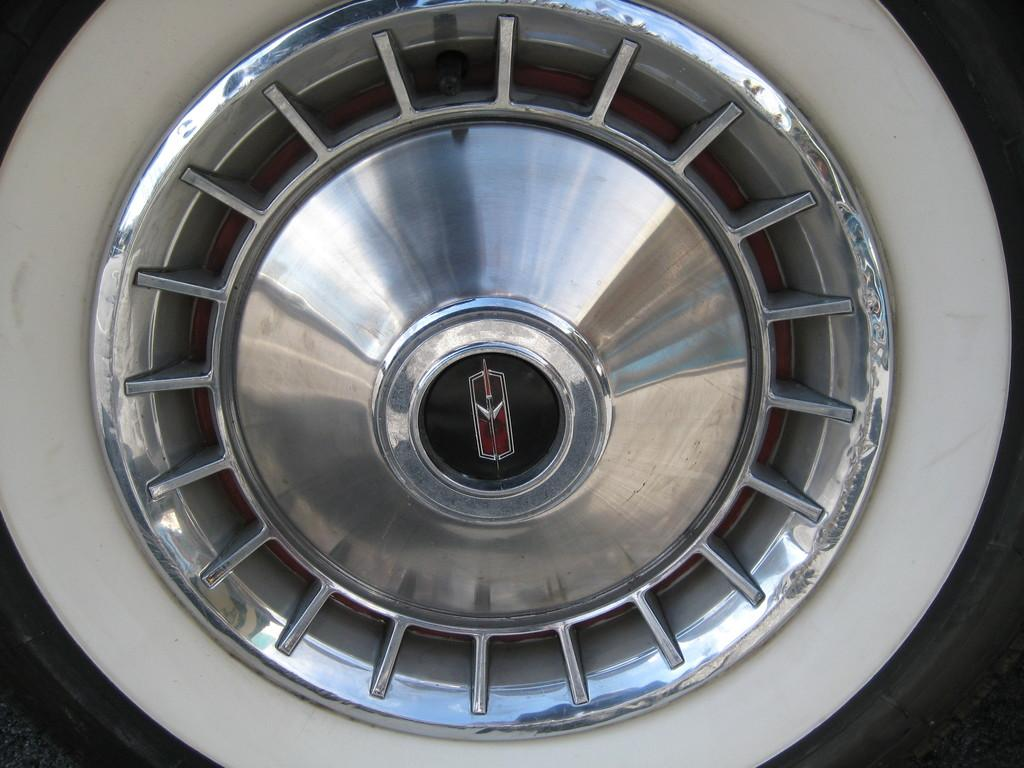What part of a vehicle or object can be seen in the image? The rim of a wheel is visible in the image. How many fingers can be seen holding the rim of the wheel in the image? There are no fingers visible in the image; only the rim of a wheel is present. 